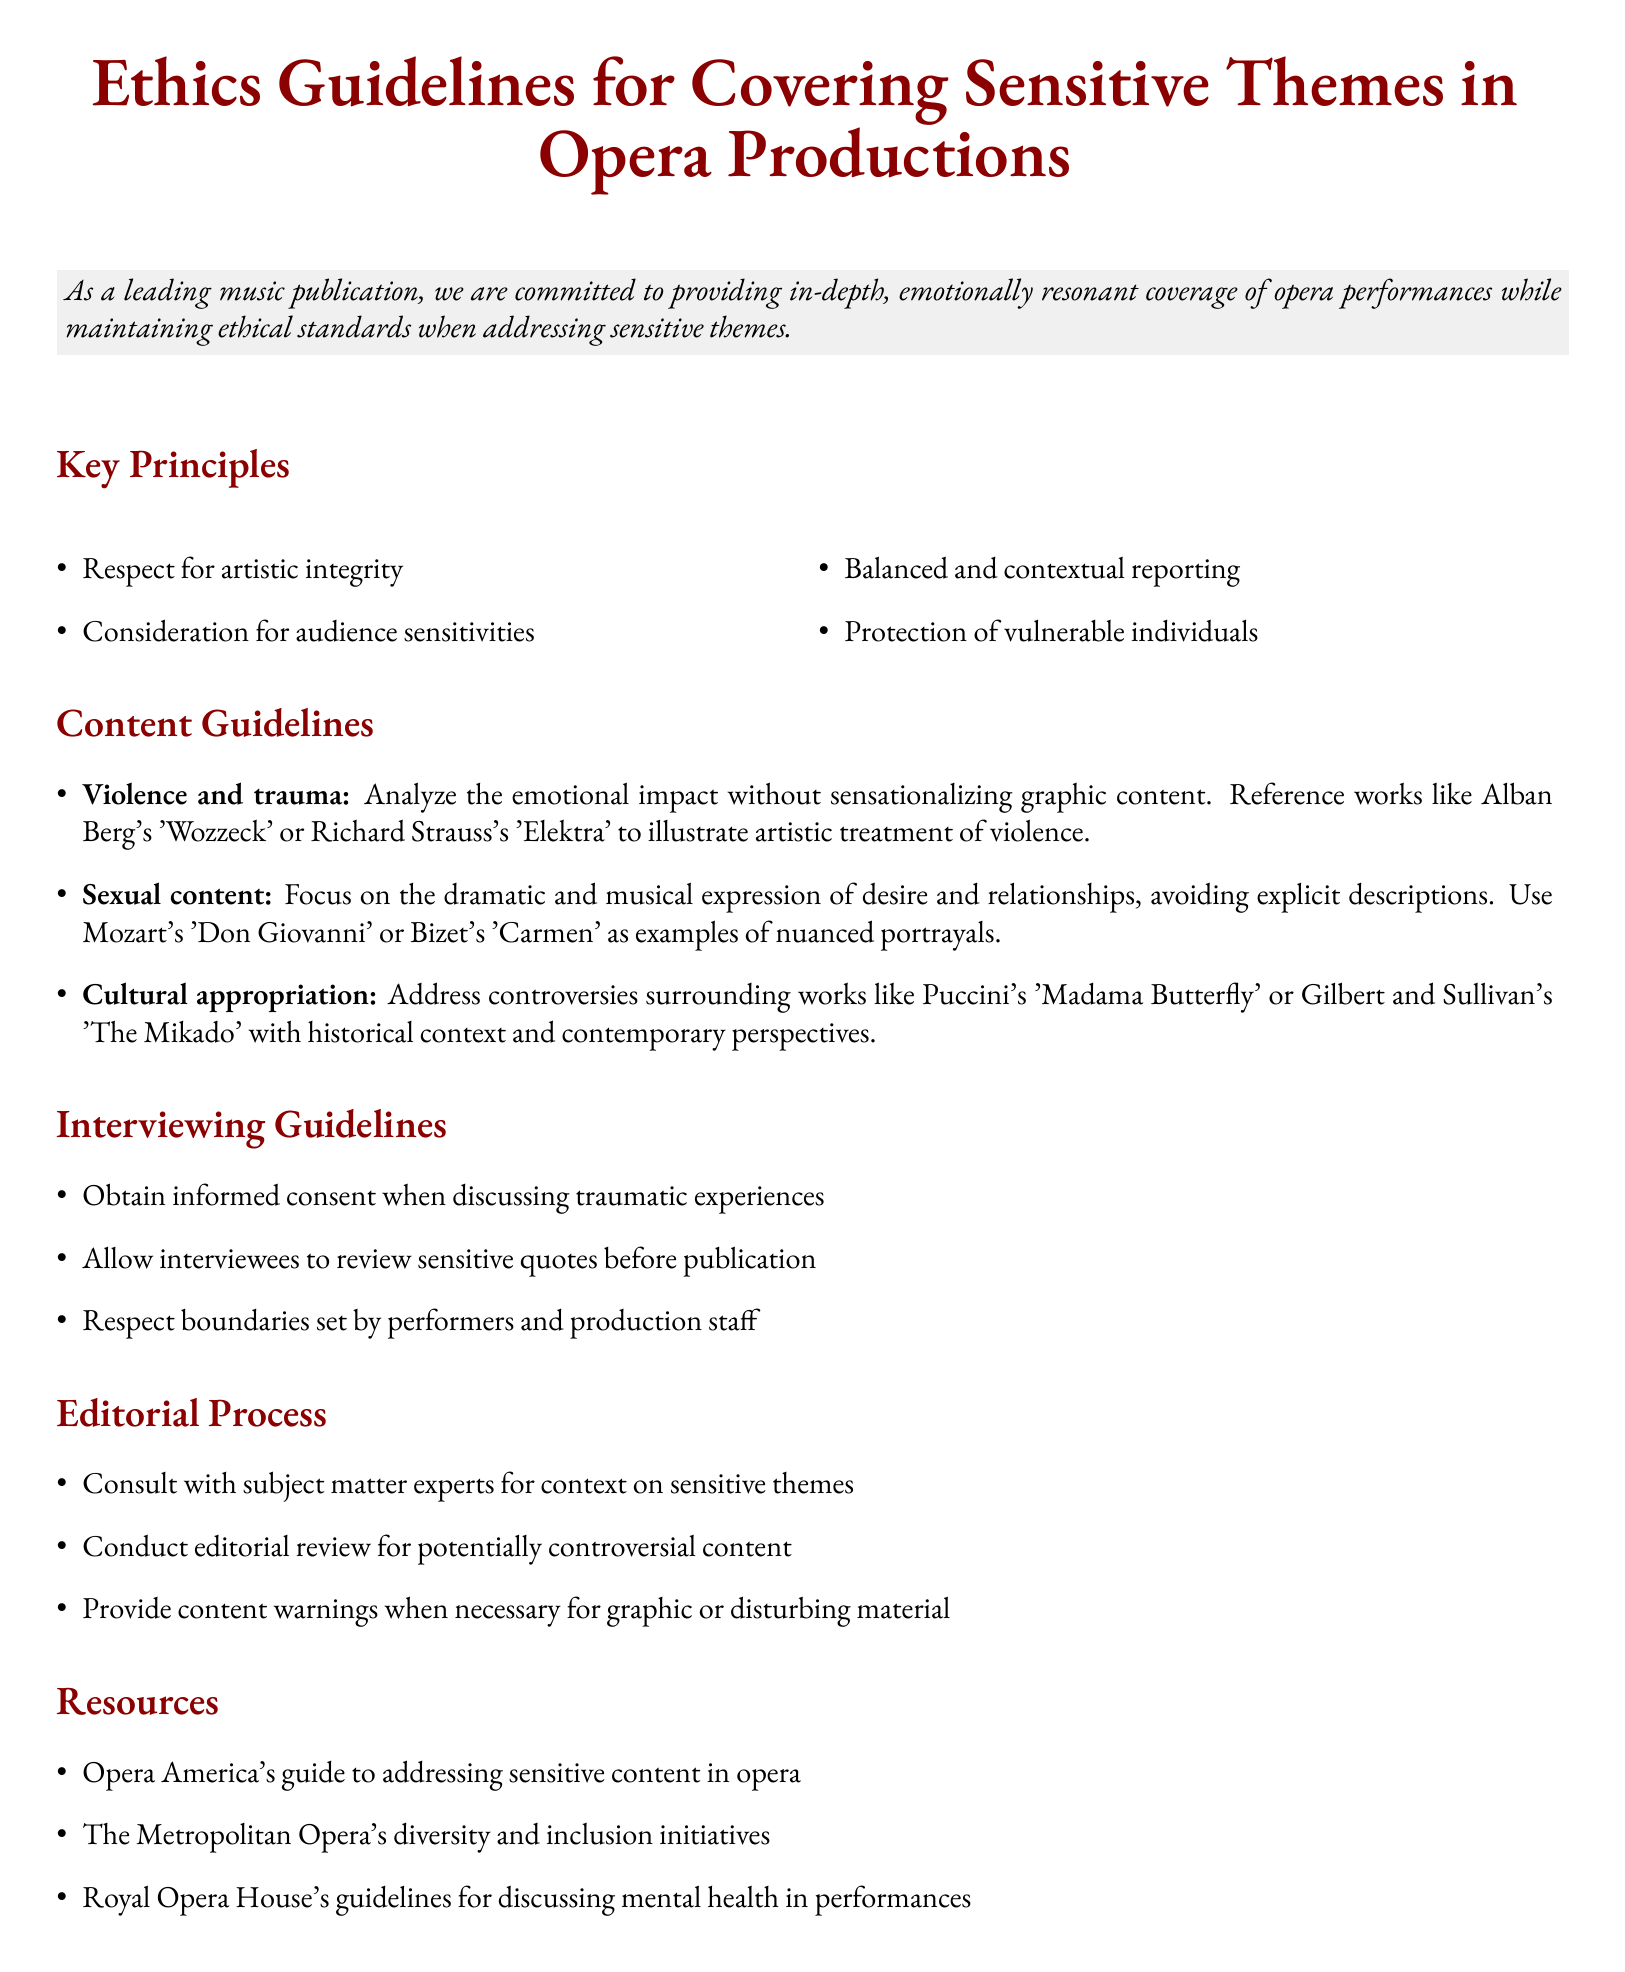What is the title of the document? The title of the document is located at the top and centered in the header section.
Answer: Ethics Guidelines for Covering Sensitive Themes in Opera Productions How many key principles are listed? The number of key principles is indicated in the relevant section of the document.
Answer: Four What is the first guideline under Content Guidelines? The first guideline under Content Guidelines addresses violence and trauma and emphasizes an important aspect.
Answer: Analyze the emotional impact without sensationalizing graphic content Which opera is referenced for cultural appropriation? The document mentions specific operas to illustrate the topic of cultural appropriation.
Answer: Madama Butterfly What is required when discussing traumatic experiences during interviews? The guideline specifies a necessary step before conducting interviews about traumatic experiences.
Answer: Obtain informed consent What resource is mentioned for addressing sensitive content in opera? The resources section lists a specific guide that can be referred to for sensitive content.
Answer: Opera America's guide to addressing sensitive content in opera What does the editorial process involve regarding controversial content? The process for handling controversial content includes a specific review step.
Answer: Conduct editorial review for potentially controversial content What should be provided for graphic or disturbing material? The document states what should be done to warn audiences about certain content types.
Answer: Content warnings 